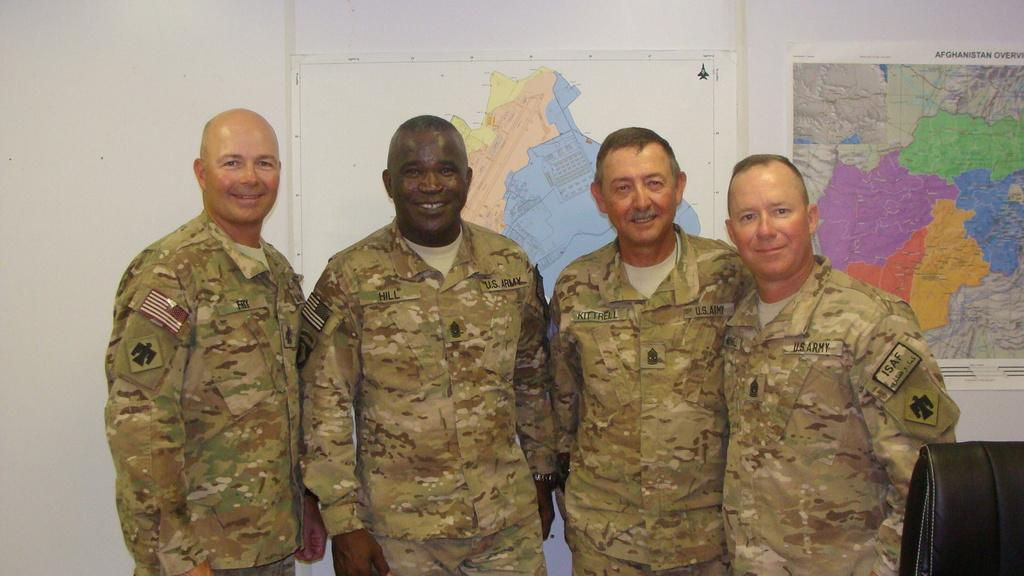How many people are in the image? There are four persons in the image. What is on the wall behind the persons? There are maps on the wall behind the persons. What is in front of the persons? There is a chair in front of the persons. What can be seen on the maps? There is text visible on the maps. What type of bead is being used by the persons in the image? There is no bead present in the image. What kind of animal can be seen accompanying the persons on their journey in the image? There is no journey or animal present in the image. 